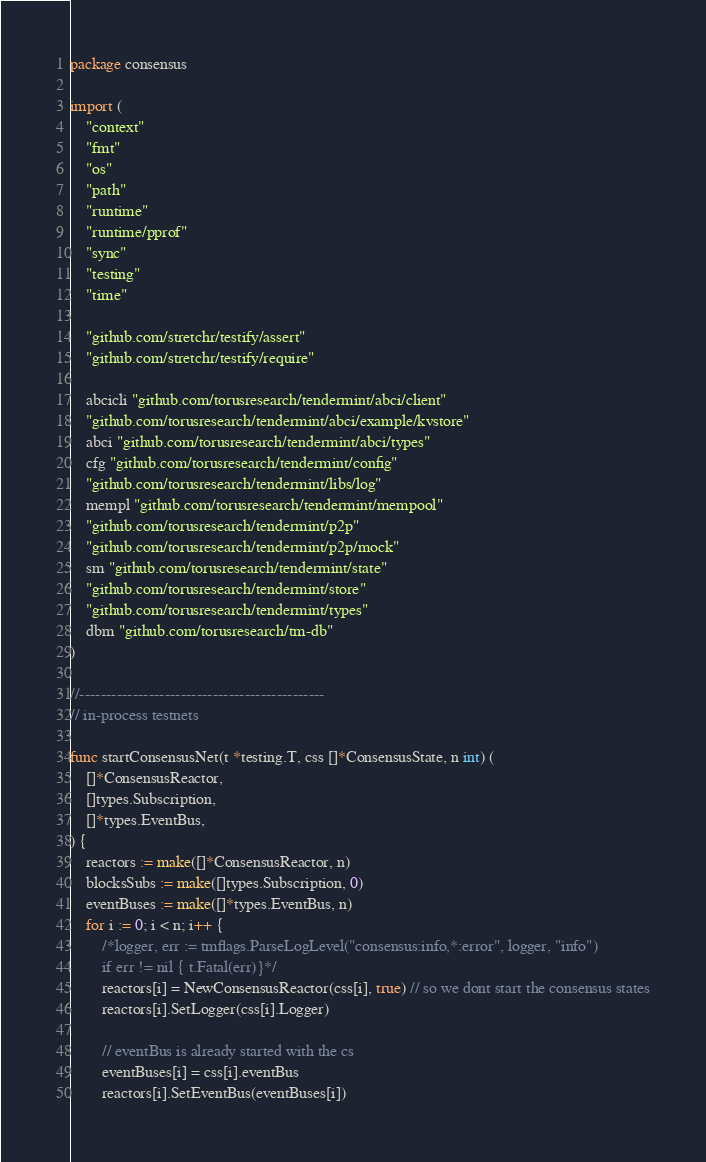<code> <loc_0><loc_0><loc_500><loc_500><_Go_>package consensus

import (
	"context"
	"fmt"
	"os"
	"path"
	"runtime"
	"runtime/pprof"
	"sync"
	"testing"
	"time"

	"github.com/stretchr/testify/assert"
	"github.com/stretchr/testify/require"

	abcicli "github.com/torusresearch/tendermint/abci/client"
	"github.com/torusresearch/tendermint/abci/example/kvstore"
	abci "github.com/torusresearch/tendermint/abci/types"
	cfg "github.com/torusresearch/tendermint/config"
	"github.com/torusresearch/tendermint/libs/log"
	mempl "github.com/torusresearch/tendermint/mempool"
	"github.com/torusresearch/tendermint/p2p"
	"github.com/torusresearch/tendermint/p2p/mock"
	sm "github.com/torusresearch/tendermint/state"
	"github.com/torusresearch/tendermint/store"
	"github.com/torusresearch/tendermint/types"
	dbm "github.com/torusresearch/tm-db"
)

//----------------------------------------------
// in-process testnets

func startConsensusNet(t *testing.T, css []*ConsensusState, n int) (
	[]*ConsensusReactor,
	[]types.Subscription,
	[]*types.EventBus,
) {
	reactors := make([]*ConsensusReactor, n)
	blocksSubs := make([]types.Subscription, 0)
	eventBuses := make([]*types.EventBus, n)
	for i := 0; i < n; i++ {
		/*logger, err := tmflags.ParseLogLevel("consensus:info,*:error", logger, "info")
		if err != nil {	t.Fatal(err)}*/
		reactors[i] = NewConsensusReactor(css[i], true) // so we dont start the consensus states
		reactors[i].SetLogger(css[i].Logger)

		// eventBus is already started with the cs
		eventBuses[i] = css[i].eventBus
		reactors[i].SetEventBus(eventBuses[i])
</code> 